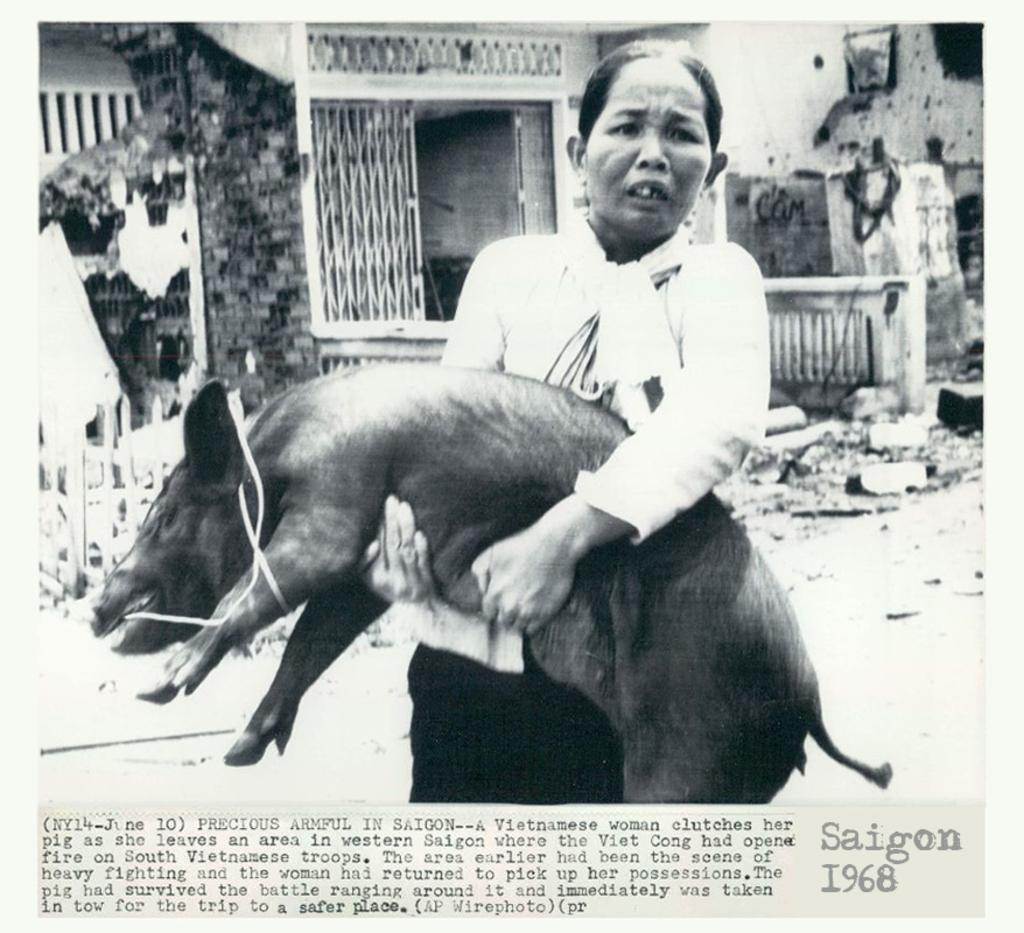Who is the main subject in the image? There is a woman in the image. What is the woman holding in her hands? The woman is holding a pig in her hands. What can be seen in the background of the image? There are buildings and grills in the background of the image. What is present at the bottom of the image? There is text at the bottom of the image. How does the actor breathe while holding the bee in the image? There is no actor or bee present in the image; it features a woman holding a pig. 